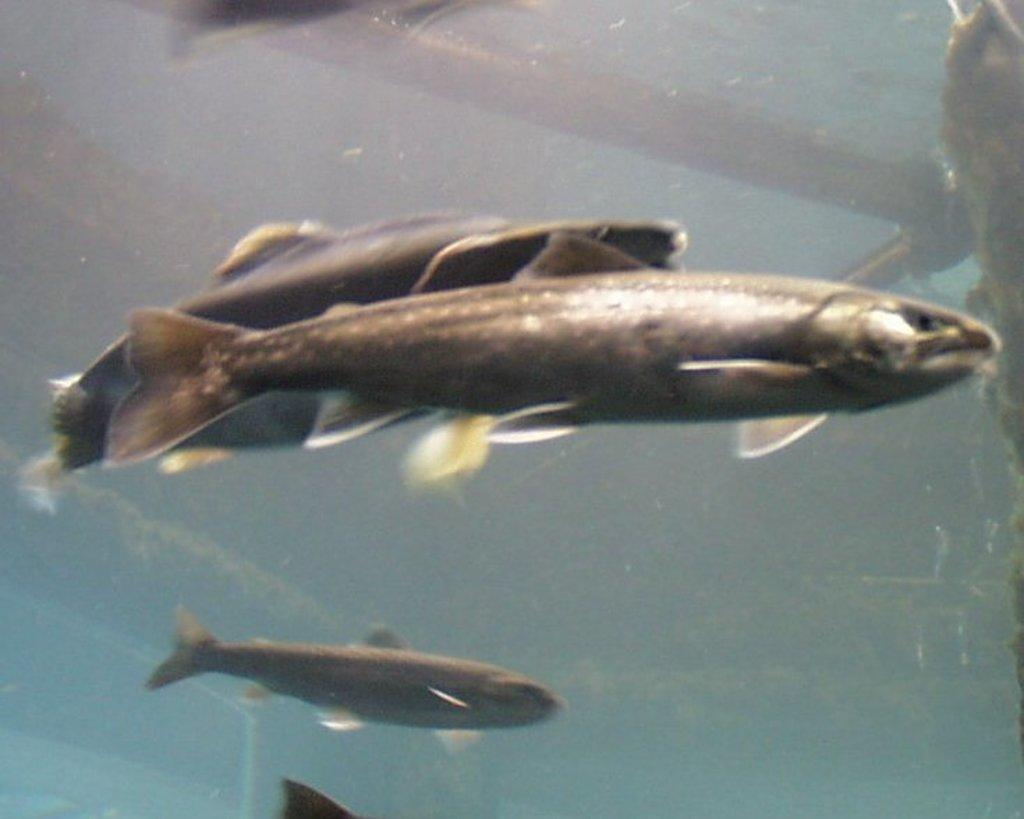What type of animals can be seen in the image? There are fishes in the image. Where are the fishes located? The fishes are in the water. What type of cork can be seen floating near the fishes in the image? There is no cork present in the image; it only features fishes in the water. 